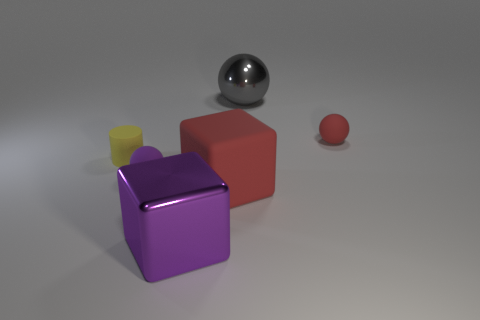Subtract all metallic spheres. How many spheres are left? 2 Add 2 green rubber cylinders. How many objects exist? 8 Subtract all cylinders. How many objects are left? 5 Add 3 red matte things. How many red matte things exist? 5 Subtract 0 green cubes. How many objects are left? 6 Subtract all cyan spheres. Subtract all green blocks. How many spheres are left? 3 Subtract all purple rubber cylinders. Subtract all big gray metallic objects. How many objects are left? 5 Add 6 small balls. How many small balls are left? 8 